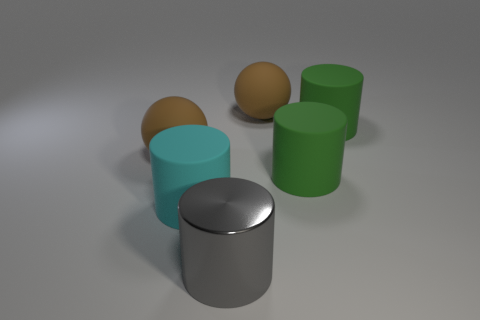Subtract all blue cylinders. Subtract all yellow balls. How many cylinders are left? 4 Add 1 large metallic objects. How many objects exist? 7 Subtract all cylinders. How many objects are left? 2 Add 5 gray things. How many gray things are left? 6 Add 6 cylinders. How many cylinders exist? 10 Subtract 1 green cylinders. How many objects are left? 5 Subtract all cyan objects. Subtract all tiny blue shiny things. How many objects are left? 5 